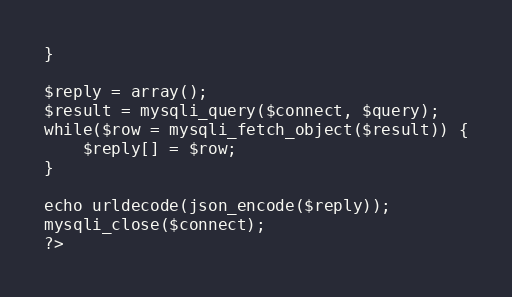<code> <loc_0><loc_0><loc_500><loc_500><_PHP_>}

$reply = array();
$result = mysqli_query($connect, $query);
while($row = mysqli_fetch_object($result)) {
	$reply[] = $row;
}

echo urldecode(json_encode($reply));
mysqli_close($connect);
?>
</code> 